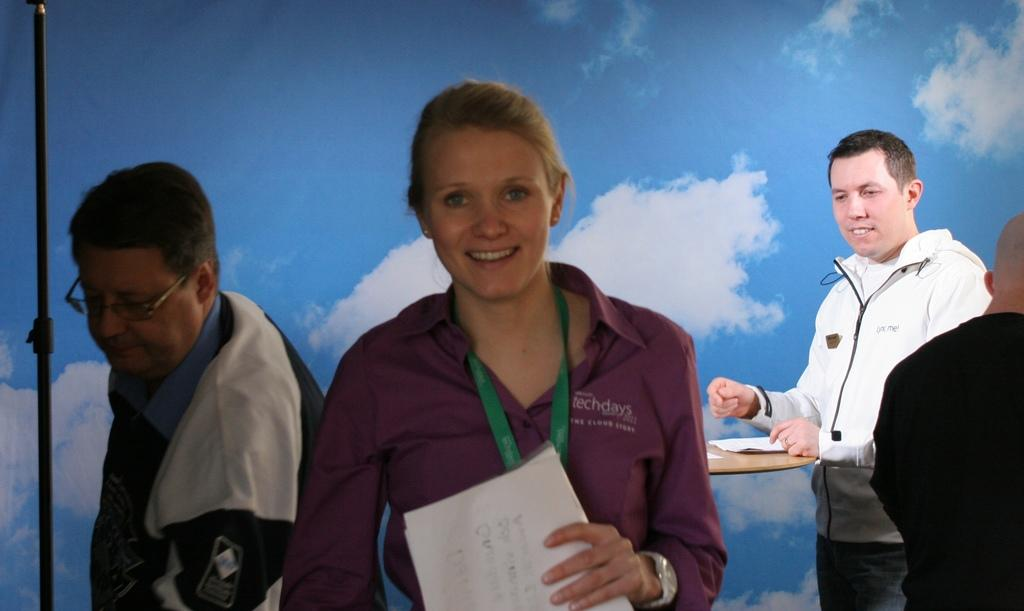What is the main subject in the foreground of the image? There is a woman in the foreground of the image. What is the woman doing in the image? The woman is standing in the image. What is the woman holding in the image? The woman is holding papers in the image. What can be seen in the background of the image? There are people in the background of the image. What is the color of the sky in the image? The sky is visible in the image, but the color is not mentioned in the provided facts. What type of space suit is the woman wearing in the image? There is no space suit or any reference to space in the image; the woman is holding papers and standing in a non-space-related setting. 